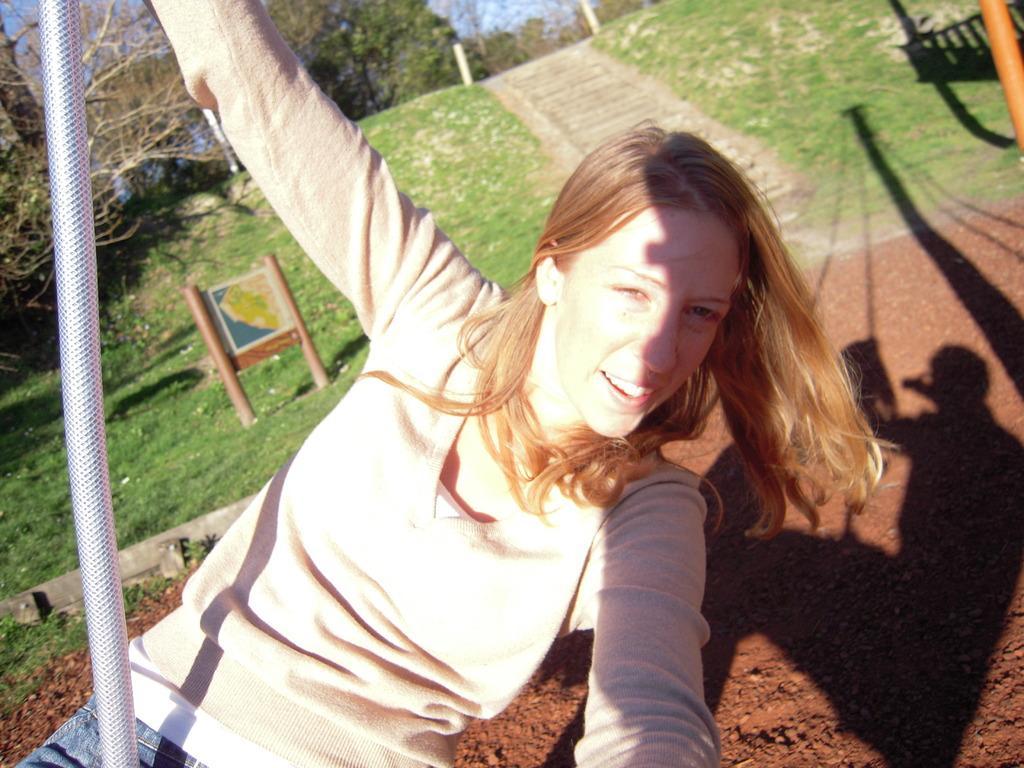Please provide a concise description of this image. In this image there is a girl holding a pole, a reflection of a person on the swing on the ground, there are few trees, poles, a board with an image and the sky. 